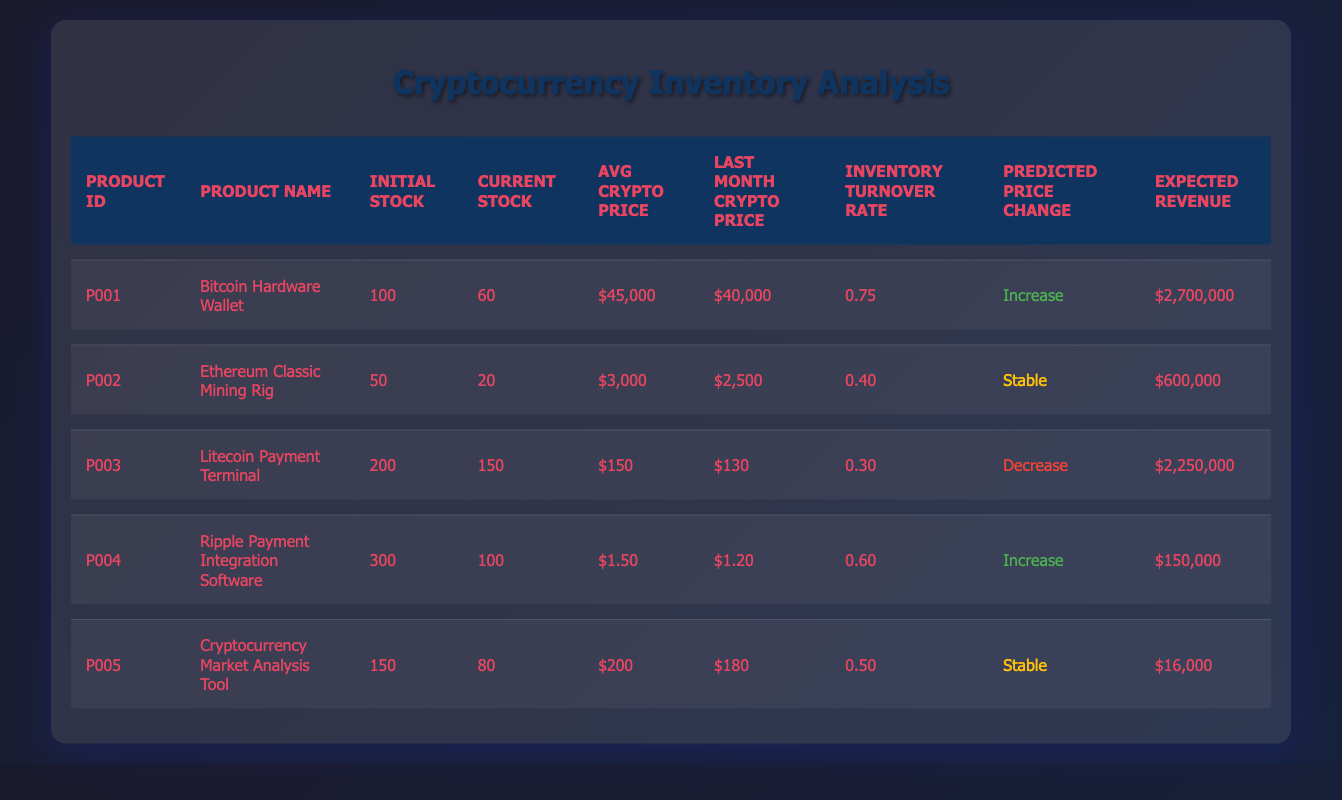What is the initial stock of the Bitcoin Hardware Wallet? Referring to the table, the initial stock for the product with ID P001 (Bitcoin Hardware Wallet) is clearly listed as 100.
Answer: 100 What is the inventory turnover rate for the Ethereum Classic Mining Rig? The table shows the inventory turnover rate for the product with ID P002 (Ethereum Classic Mining Rig) as 0.40.
Answer: 0.40 True or False: The current stock of the Litecoin Payment Terminal is higher than the initial stock. We compare the values in the table for the product with ID P003 (Litecoin Payment Terminal): initial stock is 200 and current stock is 150. Since 150 is less than 200, the statement is false.
Answer: False What is the total expected revenue from all products listed in the table? To find the total expected revenue, we sum all the expected revenues: 2,700,000 + 600,000 + 2,250,000 + 150,000 + 16,000 = 5,716,000.
Answer: 5,716,000 Which product has the highest average crypto price? We need to compare average crypto prices in the table: Bitcoin Hardware Wallet is $45,000, Ethereum Classic Mining Rig is $3,000, Litecoin Payment Terminal is $150, Ripple Software is $1.50, and Market Tool is $200. The highest price is $45,000 for the Bitcoin Hardware Wallet.
Answer: Bitcoin Hardware Wallet 